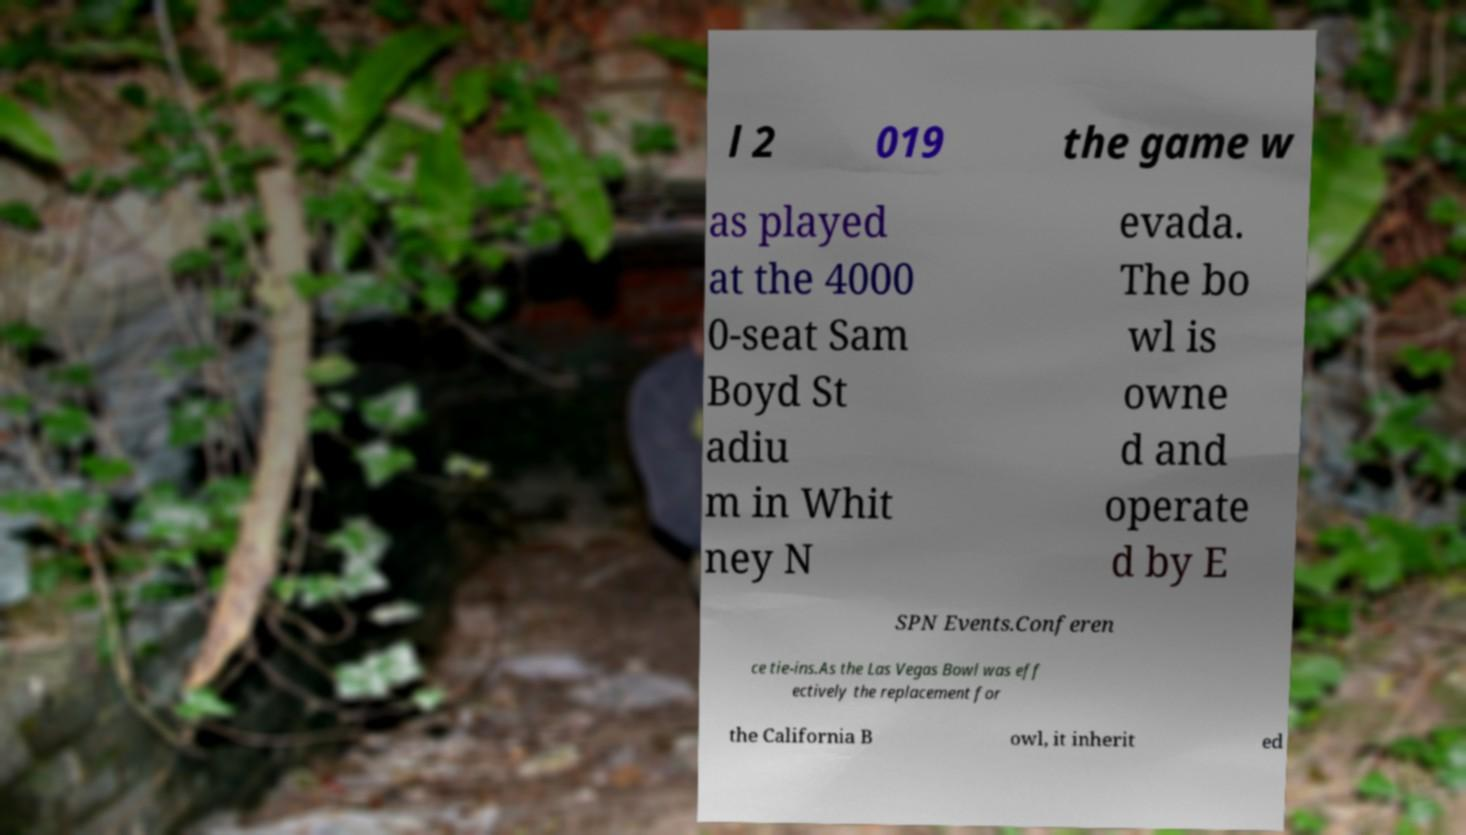Please read and relay the text visible in this image. What does it say? l 2 019 the game w as played at the 4000 0-seat Sam Boyd St adiu m in Whit ney N evada. The bo wl is owne d and operate d by E SPN Events.Conferen ce tie-ins.As the Las Vegas Bowl was eff ectively the replacement for the California B owl, it inherit ed 